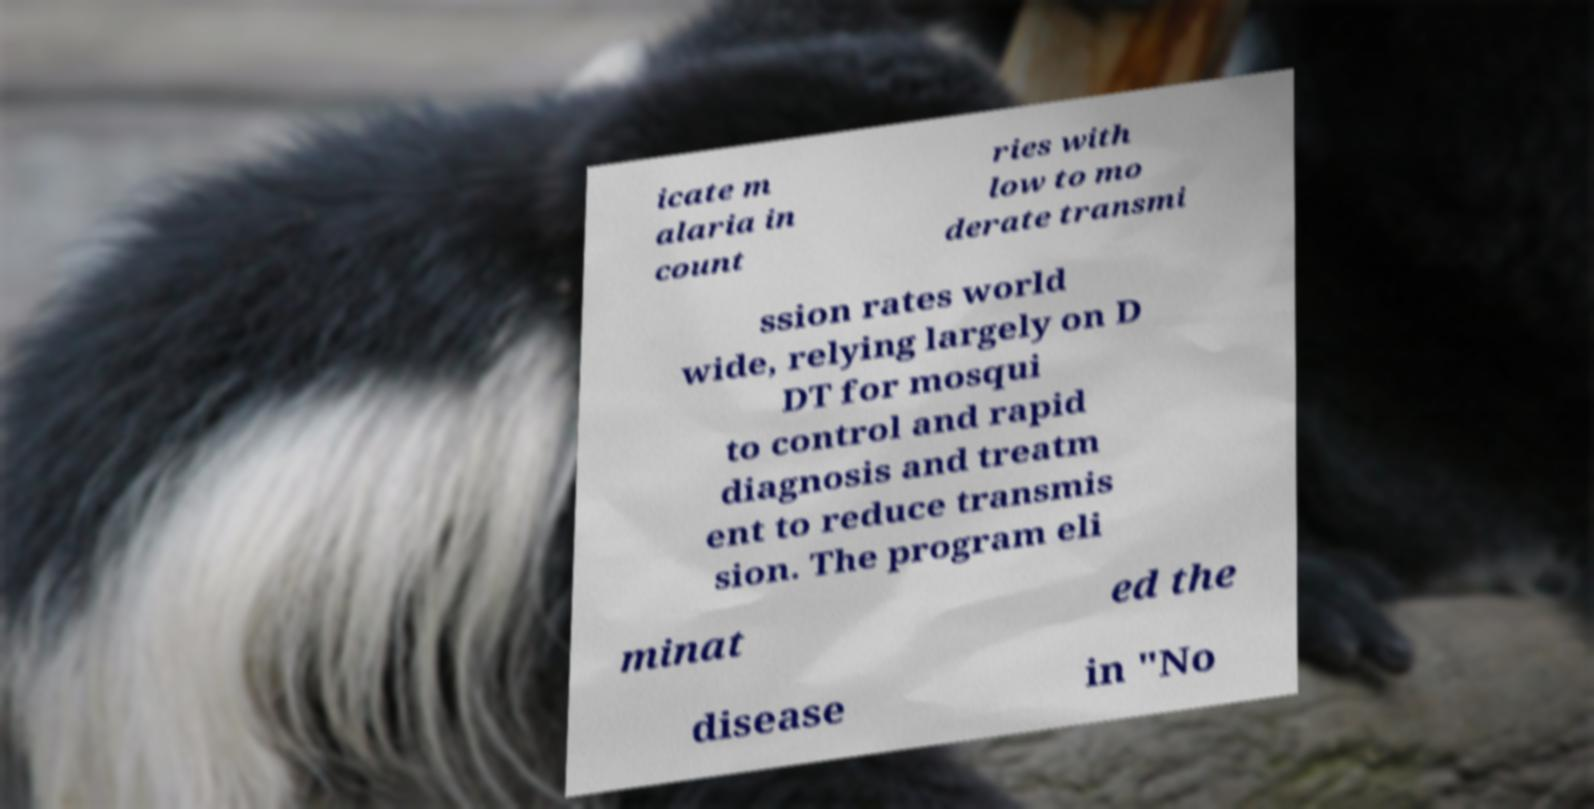Could you extract and type out the text from this image? icate m alaria in count ries with low to mo derate transmi ssion rates world wide, relying largely on D DT for mosqui to control and rapid diagnosis and treatm ent to reduce transmis sion. The program eli minat ed the disease in "No 